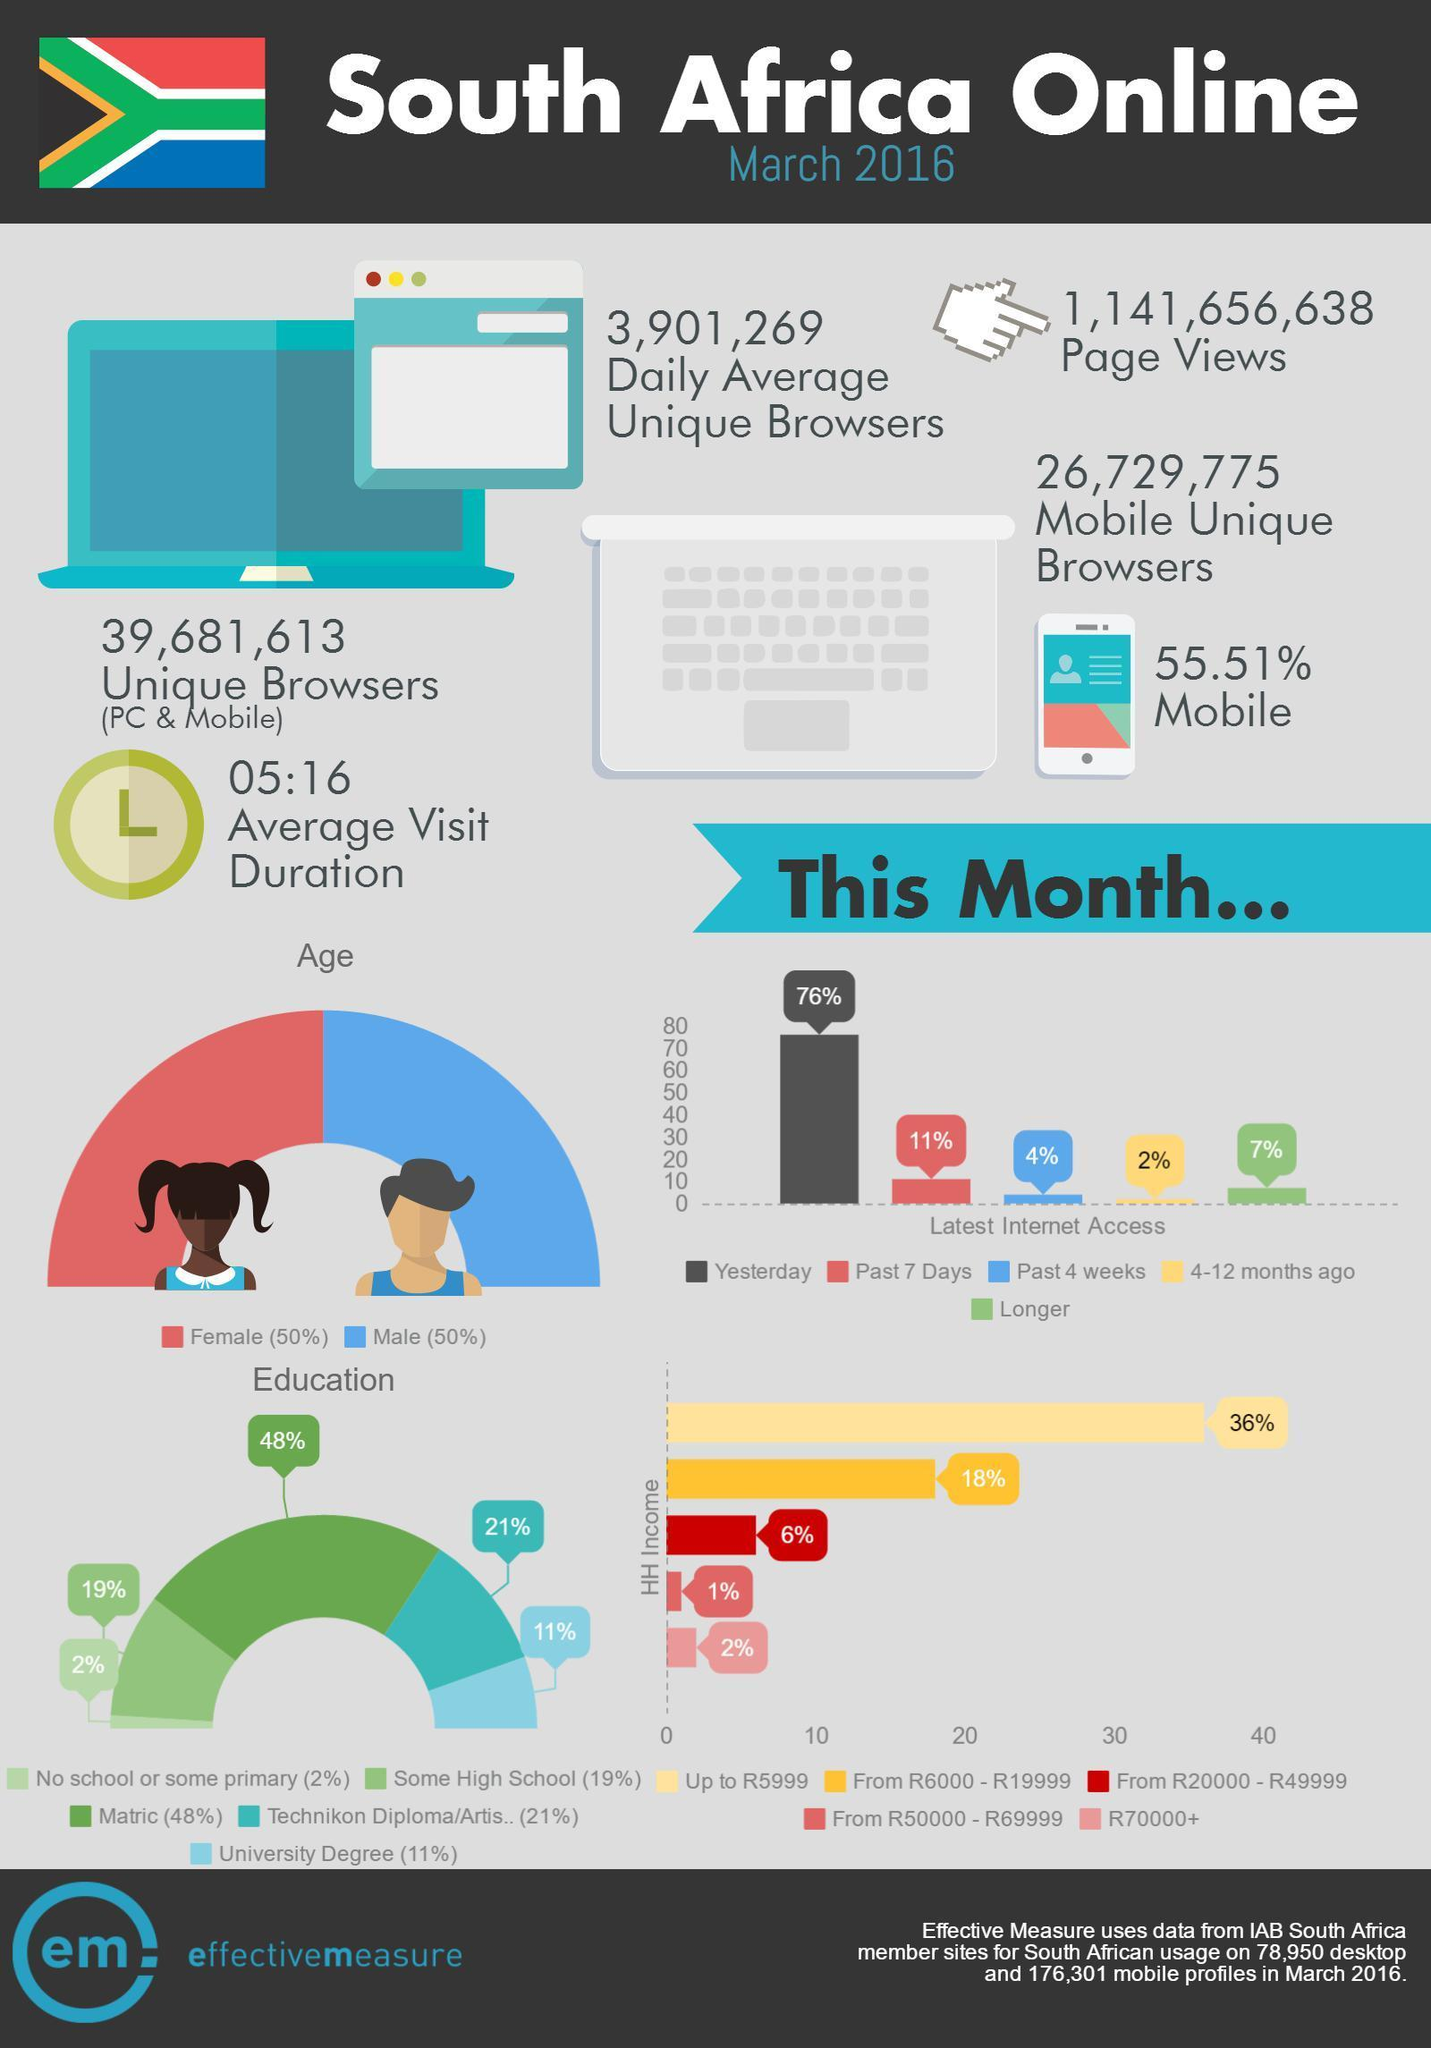What is the percent of internet access during the past 7 days?
Answer the question with a short phrase. 11% What percent of internet users have a household income of the range R50000-R69999? 1% What is the household income of 18% of internet users? From R6000 - R19999 What percent of internet access was during the past 4 weeks? 4% What percent of internet users have a household income up to R5999? 36% 2% of the internet users belong to which income group? R70000+ What percent of the latest internet access was on the previous day? 76% what is the combined percentage of internet users who have a household income above R20000? 9% 